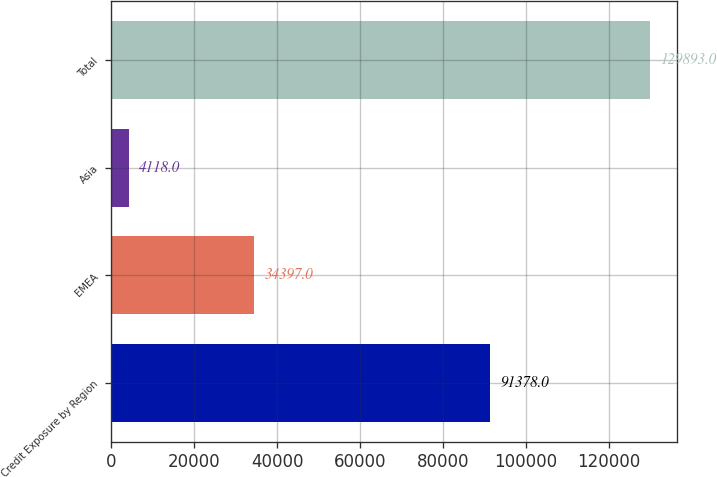Convert chart to OTSL. <chart><loc_0><loc_0><loc_500><loc_500><bar_chart><fcel>Credit Exposure by Region<fcel>EMEA<fcel>Asia<fcel>Total<nl><fcel>91378<fcel>34397<fcel>4118<fcel>129893<nl></chart> 